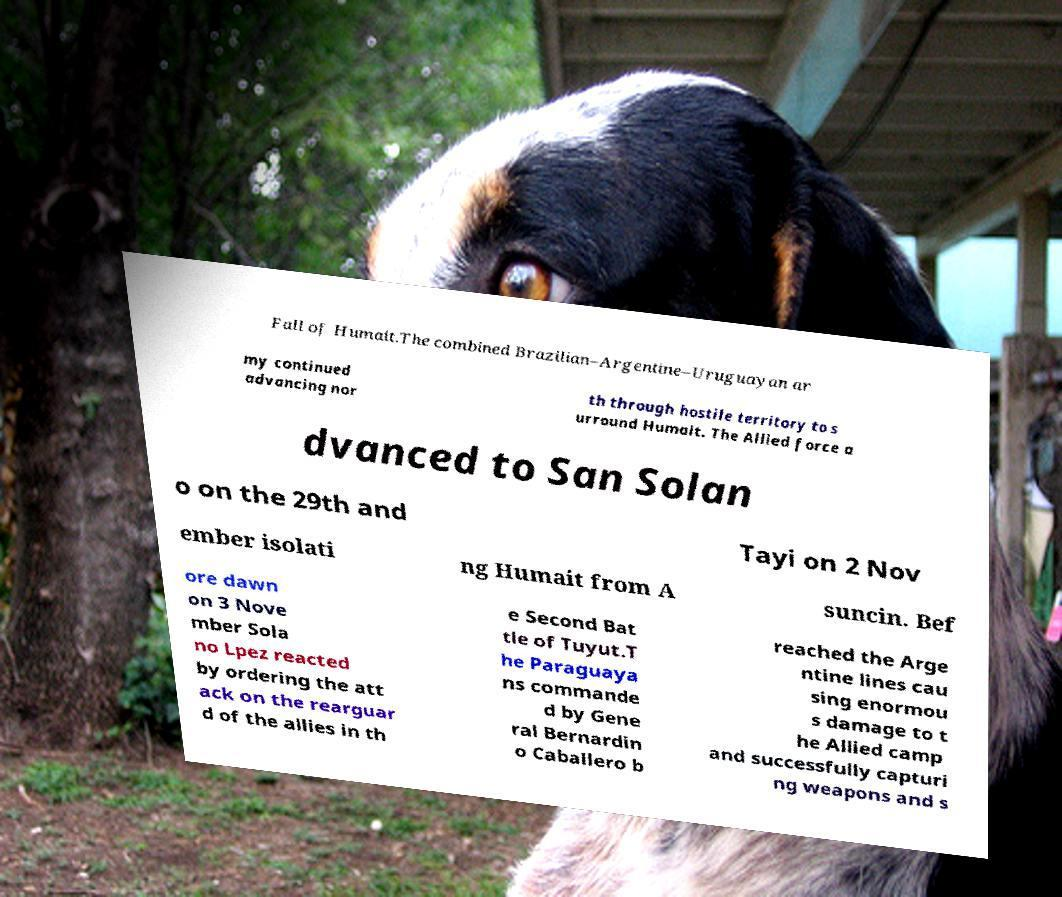Could you assist in decoding the text presented in this image and type it out clearly? Fall of Humait.The combined Brazilian–Argentine–Uruguayan ar my continued advancing nor th through hostile territory to s urround Humait. The Allied force a dvanced to San Solan o on the 29th and Tayi on 2 Nov ember isolati ng Humait from A suncin. Bef ore dawn on 3 Nove mber Sola no Lpez reacted by ordering the att ack on the rearguar d of the allies in th e Second Bat tle of Tuyut.T he Paraguaya ns commande d by Gene ral Bernardin o Caballero b reached the Arge ntine lines cau sing enormou s damage to t he Allied camp and successfully capturi ng weapons and s 